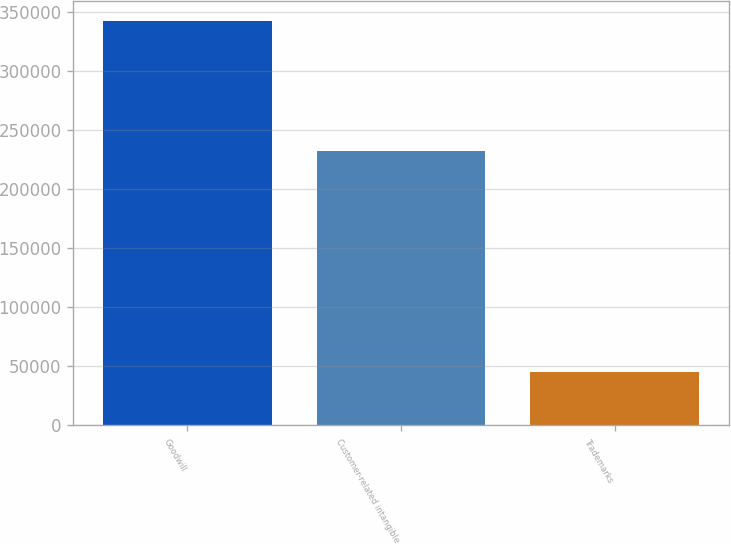Convert chart to OTSL. <chart><loc_0><loc_0><loc_500><loc_500><bar_chart><fcel>Goodwill<fcel>Customer-related intangible<fcel>Trademarks<nl><fcel>342012<fcel>232318<fcel>45108<nl></chart> 